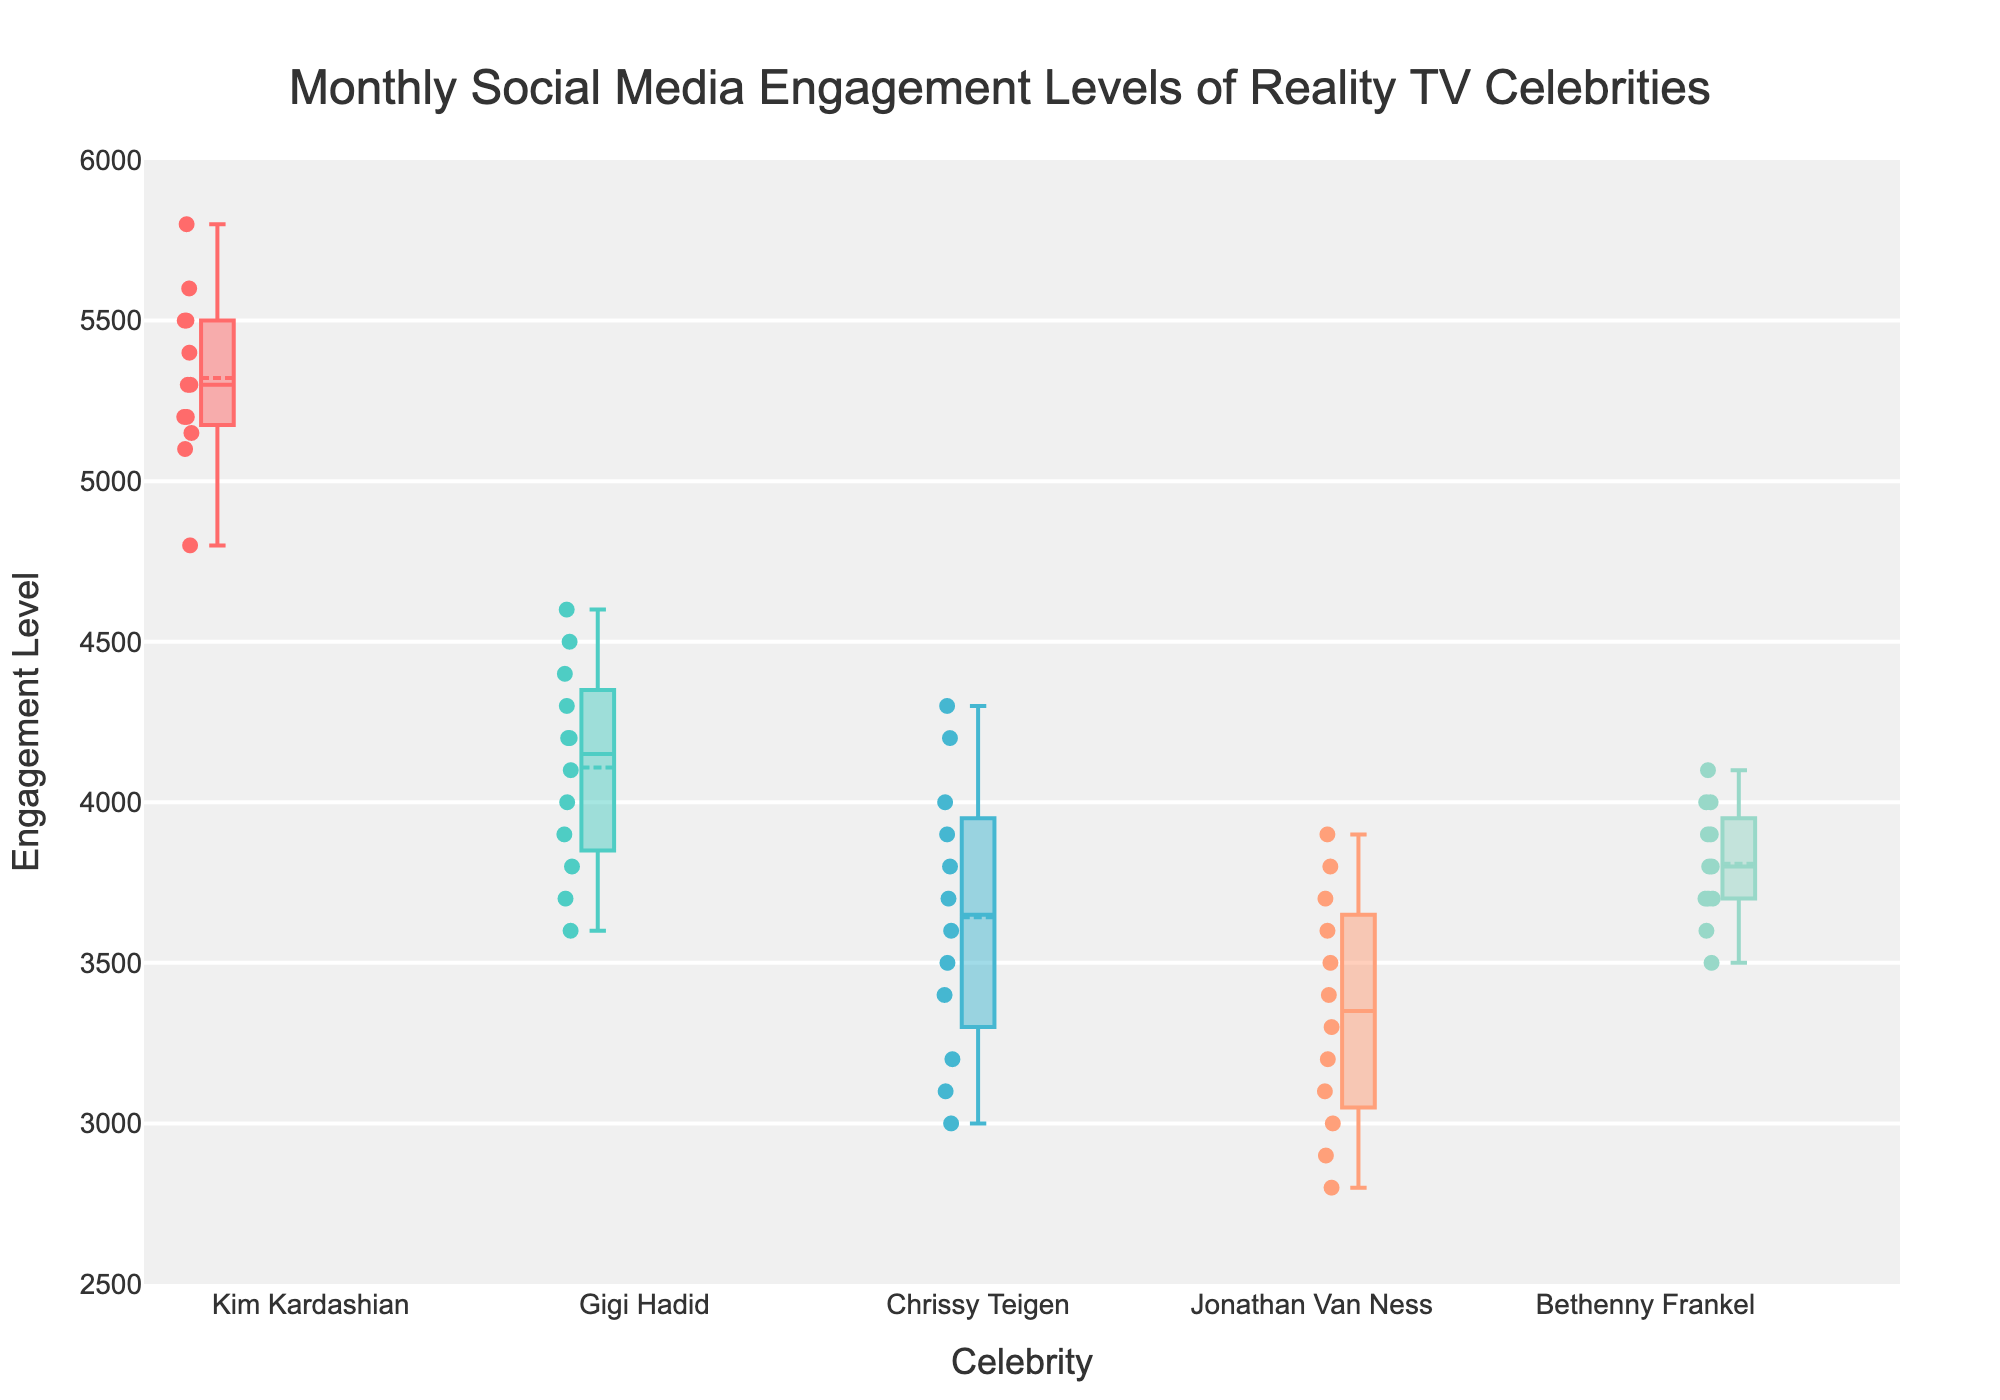What is the title of the figure? The title is located at the top, center of the figure in a larger font size.
Answer: Monthly Social Media Engagement Levels of Reality TV Celebrities How many celebrities are shown in the box plot? Count the number of unique boxes or names along the x-axis.
Answer: 5 Which celebrity has the highest median engagement level? Identify the middle line (median) inside each box and compare their heights.
Answer: Kim Kardashian Which celebrity has the lowest maximum engagement level? Locate the upper whisker (top horizontal line) of each box plot and compare their heights.
Answer: Jonathan Van Ness What is the range of engagement levels for Kim Kardashian? The range is determined by the difference between the upper and lower whiskers of Kim Kardashian's box plot.
Answer: 4800 to 5800 Compare the median engagement levels of Gigi Hadid and Bethenny Frankel. Who has a higher median? Identify the median line inside each box and compare the two.
Answer: Bethenny Frankel Which celebrity shows the most variation in their engagement levels? The variation can be observed by looking at the overall spread (height) of the box and whiskers.
Answer: Kim Kardashian What is the interquartile range (IQR) for Chrissy Teigen's engagement levels? The IQR is calculated by finding the difference between the 75th percentile (upper edge of the box) and the 25th percentile (lower edge of the box).
Answer: 200 Identify the outliers for Jonathan Van Ness. Outliers are marked as individual points outside the whiskers of the box plot. Locate these points for Jonathan Van Ness.
Answer: None 